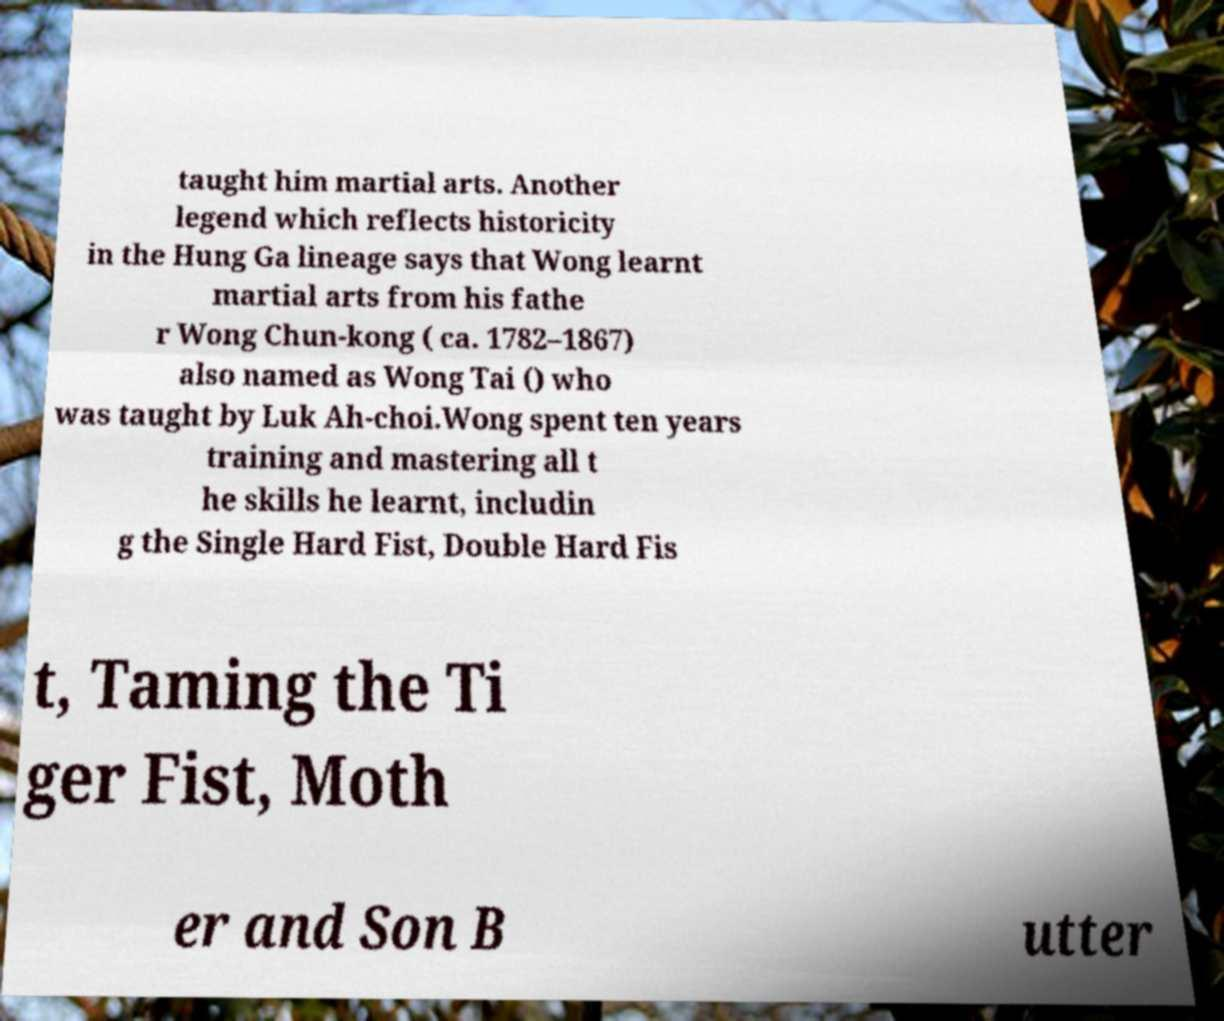Could you assist in decoding the text presented in this image and type it out clearly? taught him martial arts. Another legend which reflects historicity in the Hung Ga lineage says that Wong learnt martial arts from his fathe r Wong Chun-kong ( ca. 1782–1867) also named as Wong Tai () who was taught by Luk Ah-choi.Wong spent ten years training and mastering all t he skills he learnt, includin g the Single Hard Fist, Double Hard Fis t, Taming the Ti ger Fist, Moth er and Son B utter 